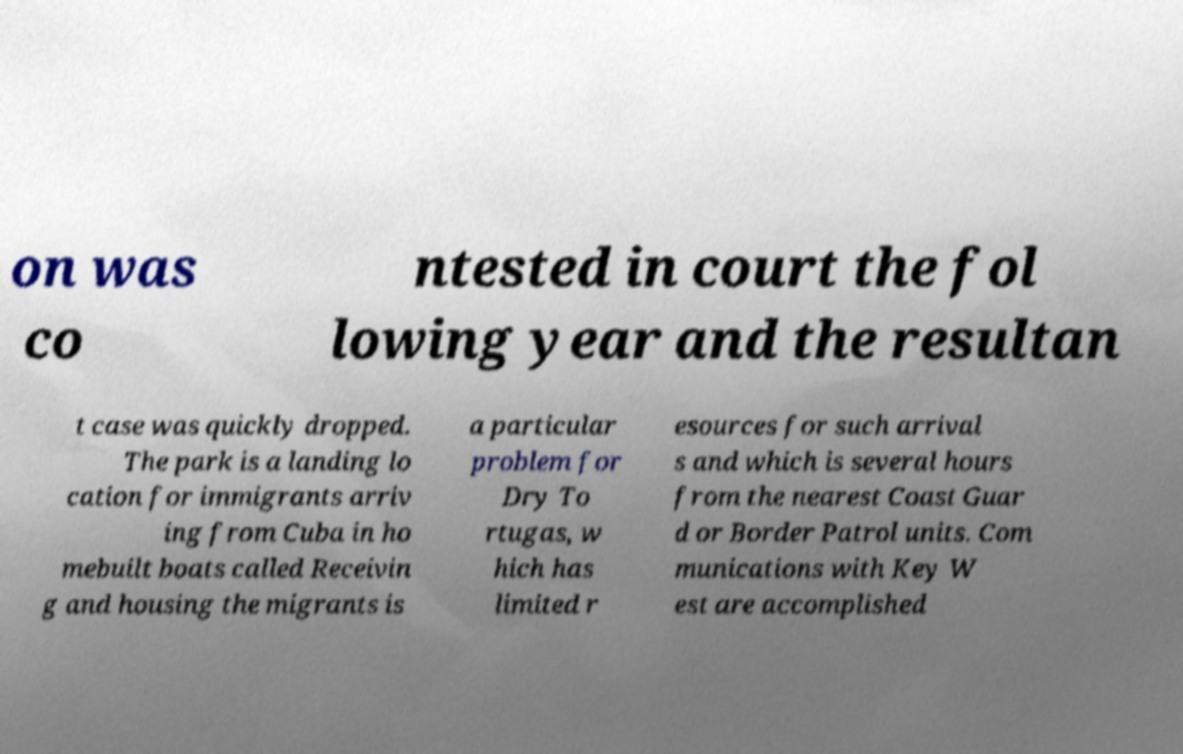Could you assist in decoding the text presented in this image and type it out clearly? on was co ntested in court the fol lowing year and the resultan t case was quickly dropped. The park is a landing lo cation for immigrants arriv ing from Cuba in ho mebuilt boats called Receivin g and housing the migrants is a particular problem for Dry To rtugas, w hich has limited r esources for such arrival s and which is several hours from the nearest Coast Guar d or Border Patrol units. Com munications with Key W est are accomplished 